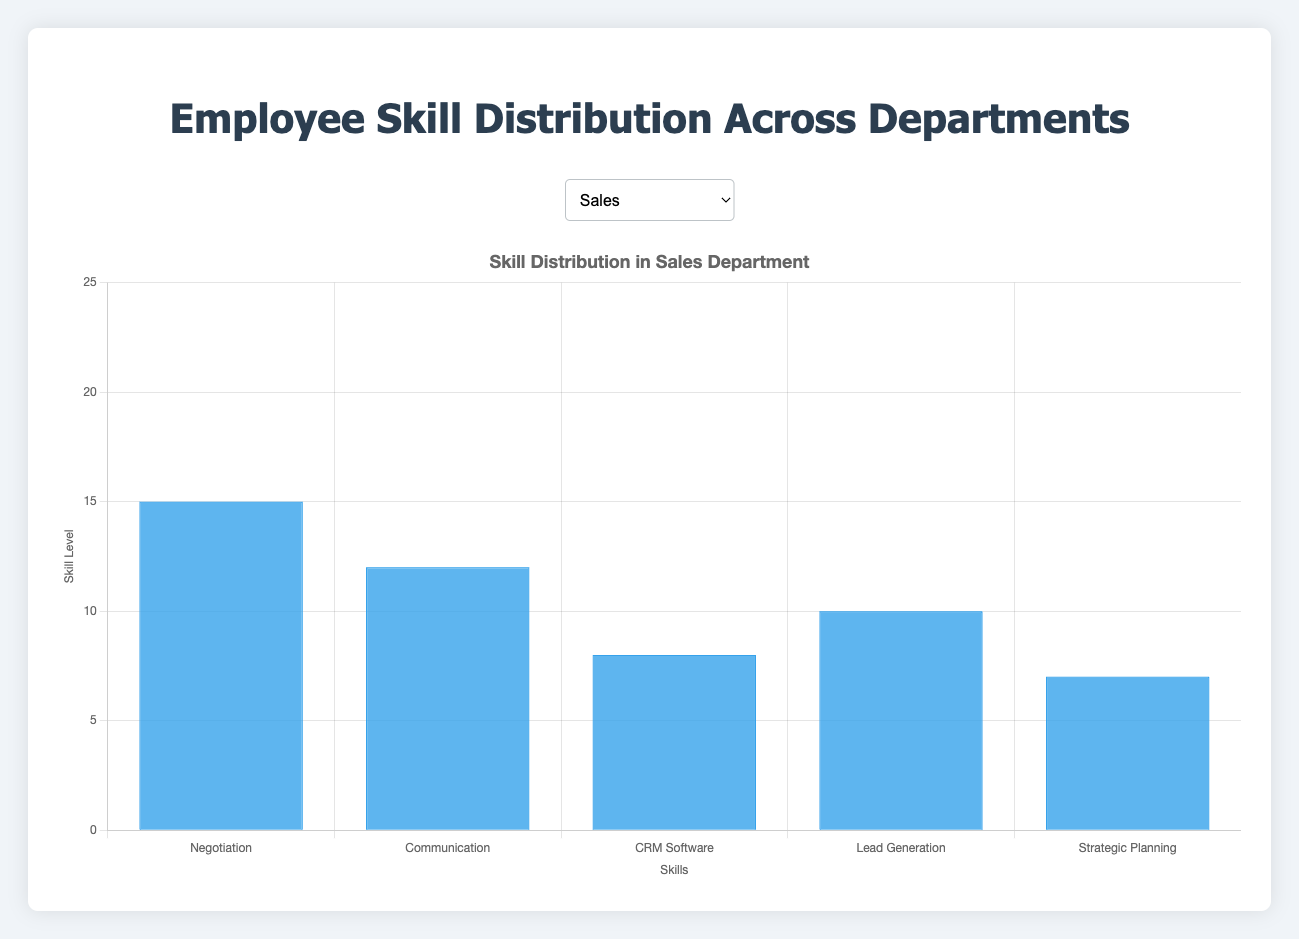Which department has the highest number of employees skilled in Communication? To identify this, look at the bar lengths for "Communication" across all department charts. The Customer Service department has the highest bar for Communication with 20.
Answer: Customer Service What is the total number of employees skilled in "Compliance" across all departments? Sum up the number of employees skilled in "Compliance" from Finance (7) and HR (9). Thus, 7 + 9 = 16.
Answer: 16 How many more employees in IT are skilled in Programming compared to Database Management? Subtract the number of employees in IT skilled in Database Management (10) from those skilled in Programming (20). The difference is 20 - 10 = 10.
Answer: 10 Which skill is most prevalent in the Marketing department? Look for the tallest bar in the Marketing department chart. The tallest bar represents "Social Media" with 20.
Answer: Social Media What is the average skill level for "Taxation" and "Budgeting" in the Finance department? Sum the values for "Taxation" (10) and "Budgeting" (15) and then divide by 2. Therefore, (10 + 15) / 2 = 12.5.
Answer: 12.5 Which department has fewer employees skilled in "Technical Support" than "System Administration"? Check the IT department's chart where "System Administration" has 15 employees and "Technical Support" has 13, thus Technical Support has fewer.
Answer: IT In the R&D department, what is the difference in the number of employees skilled in "Product Development" and "Innovation Management"? Subtract the number for "Innovation Management" (13) from "Product Development" (15). The result is 15 - 13 = 2.
Answer: 2 Which skill appears equally distributed in both the Finance and HR departments? Both have the same number of employees skilled in "Compliance" which is 7.
Answer: Compliance Compare the number of employees skilled in "Lead Generation" in Sales versus skilled in "Empathy" in Customer Service. Which has more? "Lead Generation" in Sales has 10, and "Empathy" in Customer Service has 12. Comparing the two, Empathy has more.
Answer: Empathy in Customer Service What is the sum of employees skilled in "PPC Advertising" and "SEO" in the Marketing department? Add the values for "PPC Advertising" (10) and "SEO" (14). Therefore, 10 + 14 = 24.
Answer: 24 